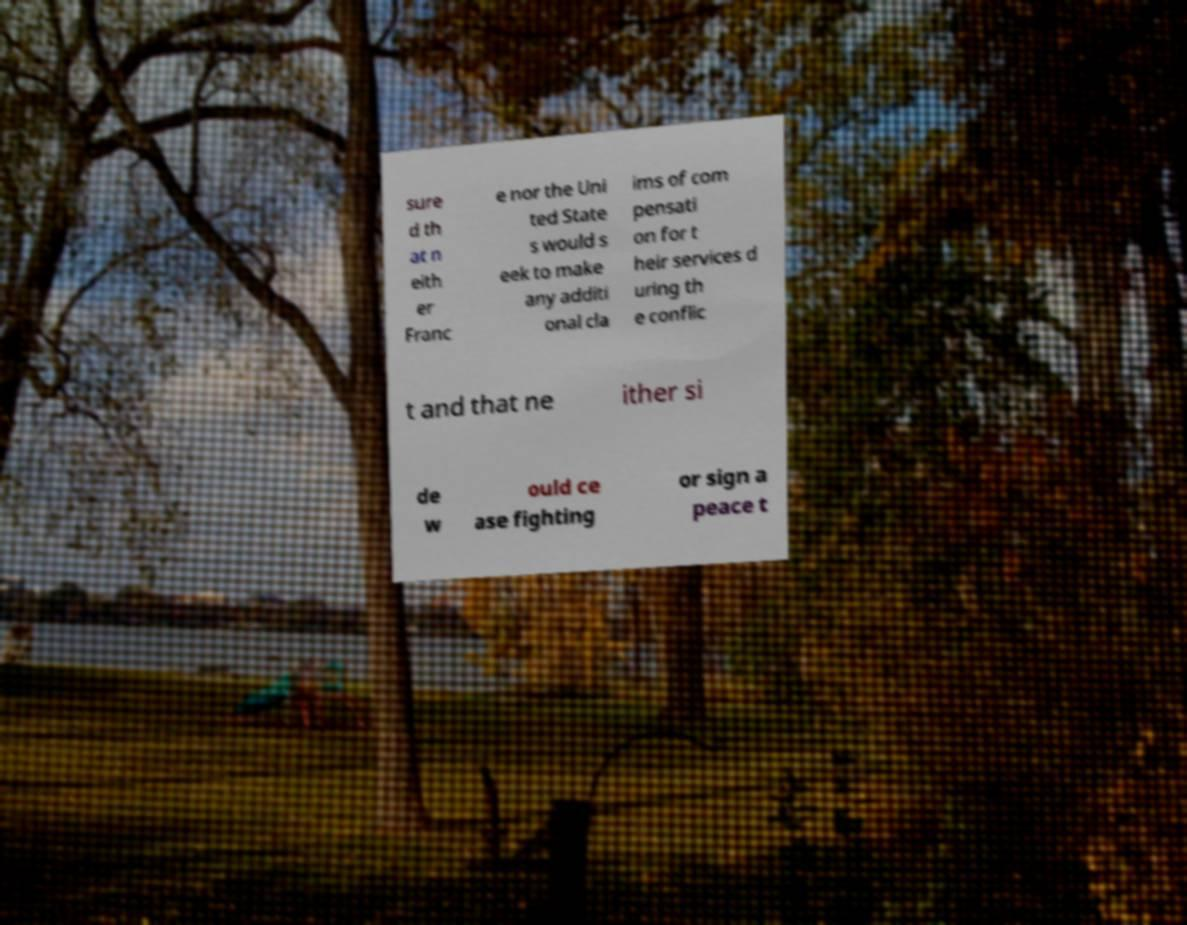Can you accurately transcribe the text from the provided image for me? sure d th at n eith er Franc e nor the Uni ted State s would s eek to make any additi onal cla ims of com pensati on for t heir services d uring th e conflic t and that ne ither si de w ould ce ase fighting or sign a peace t 